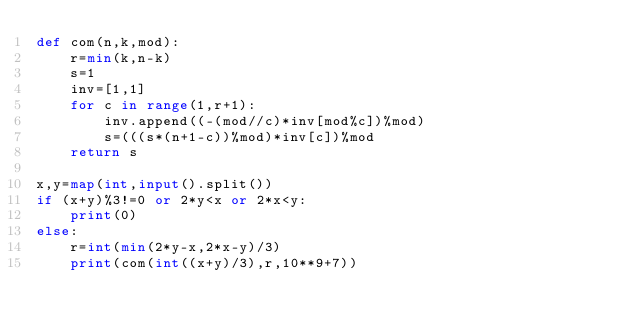Convert code to text. <code><loc_0><loc_0><loc_500><loc_500><_Python_>def com(n,k,mod):
    r=min(k,n-k)
    s=1
    inv=[1,1]
    for c in range(1,r+1):
        inv.append((-(mod//c)*inv[mod%c])%mod)
        s=(((s*(n+1-c))%mod)*inv[c])%mod
    return s

x,y=map(int,input().split())
if (x+y)%3!=0 or 2*y<x or 2*x<y:
    print(0)
else:
    r=int(min(2*y-x,2*x-y)/3)
    print(com(int((x+y)/3),r,10**9+7))</code> 